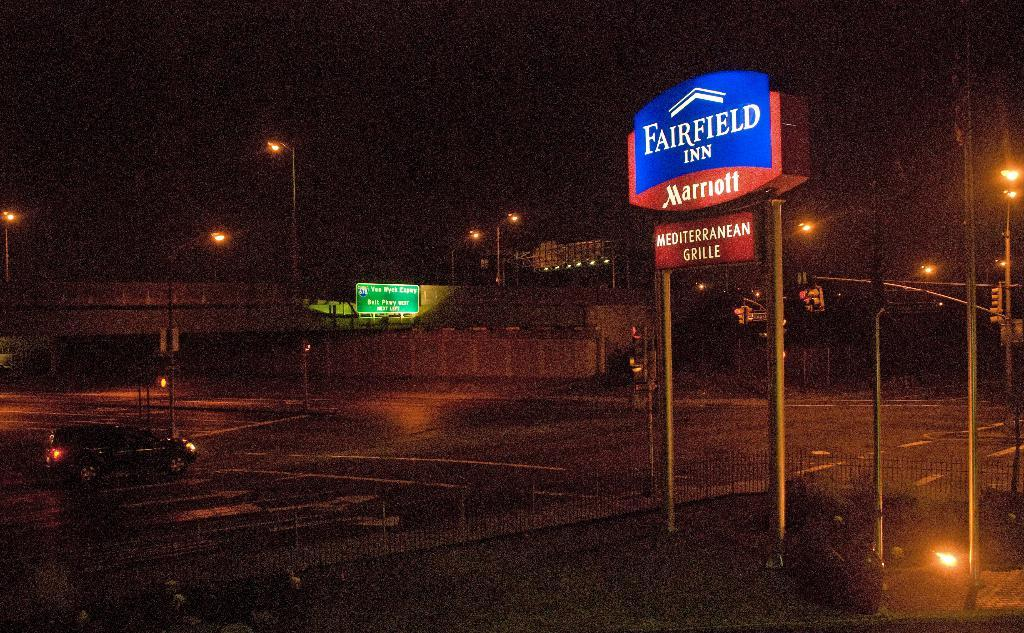What is happening on the road in the image? There is a car passing on the road in the image. What structure is located near the road? There is a bridge beside the car. What type of lighting is present in the image? Lamp posts are present in the image. What can be seen to indicate the location or direction in the image? Name boards are visible in the image. What is used to separate the road from other areas in the image? A metal fence is in the image. What helps regulate traffic in the image? Traffic lights are present in the image. What type of punishment is being given to the car in the image? There is no punishment being given to the car in the image; it is simply passing on the road. What is the car paying attention to in the image? The car is not shown paying attention to anything in particular in the image. 